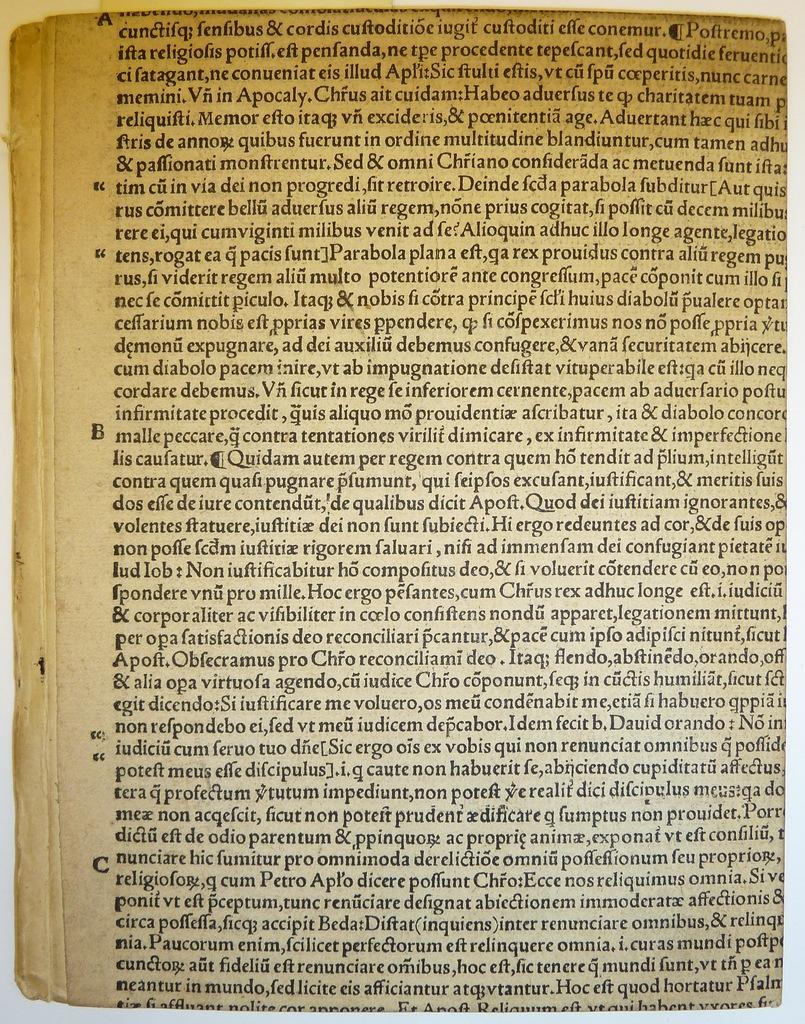Provide a one-sentence caption for the provided image. A page of a book with words such as Quidam and autem on it. 